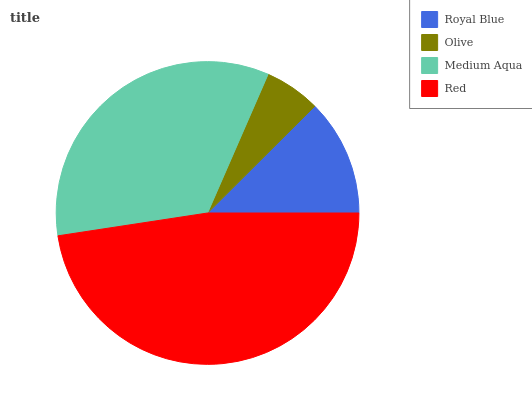Is Olive the minimum?
Answer yes or no. Yes. Is Red the maximum?
Answer yes or no. Yes. Is Medium Aqua the minimum?
Answer yes or no. No. Is Medium Aqua the maximum?
Answer yes or no. No. Is Medium Aqua greater than Olive?
Answer yes or no. Yes. Is Olive less than Medium Aqua?
Answer yes or no. Yes. Is Olive greater than Medium Aqua?
Answer yes or no. No. Is Medium Aqua less than Olive?
Answer yes or no. No. Is Medium Aqua the high median?
Answer yes or no. Yes. Is Royal Blue the low median?
Answer yes or no. Yes. Is Royal Blue the high median?
Answer yes or no. No. Is Olive the low median?
Answer yes or no. No. 